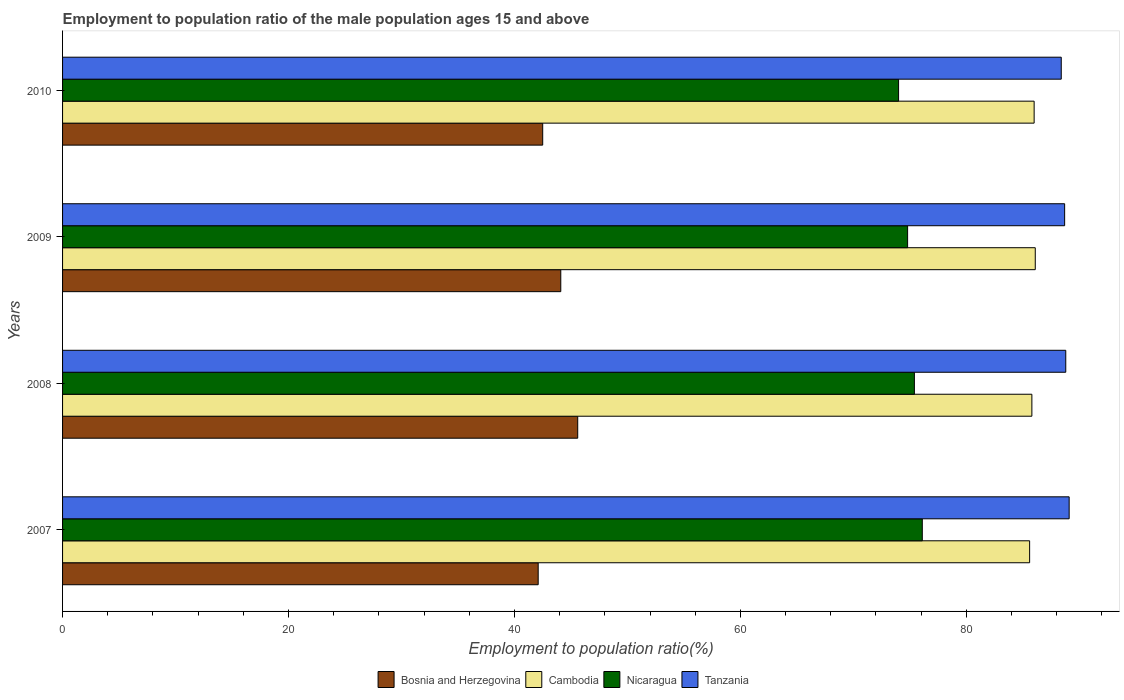How many different coloured bars are there?
Keep it short and to the point. 4. How many groups of bars are there?
Keep it short and to the point. 4. How many bars are there on the 4th tick from the top?
Provide a succinct answer. 4. What is the label of the 4th group of bars from the top?
Offer a terse response. 2007. In how many cases, is the number of bars for a given year not equal to the number of legend labels?
Keep it short and to the point. 0. What is the employment to population ratio in Nicaragua in 2008?
Your response must be concise. 75.4. Across all years, what is the maximum employment to population ratio in Nicaragua?
Your response must be concise. 76.1. Across all years, what is the minimum employment to population ratio in Bosnia and Herzegovina?
Your response must be concise. 42.1. In which year was the employment to population ratio in Nicaragua maximum?
Offer a very short reply. 2007. In which year was the employment to population ratio in Cambodia minimum?
Your answer should be compact. 2007. What is the total employment to population ratio in Nicaragua in the graph?
Your answer should be compact. 300.3. What is the difference between the employment to population ratio in Tanzania in 2009 and that in 2010?
Provide a short and direct response. 0.3. What is the difference between the employment to population ratio in Tanzania in 2010 and the employment to population ratio in Nicaragua in 2009?
Your answer should be very brief. 13.6. What is the average employment to population ratio in Cambodia per year?
Keep it short and to the point. 85.87. In the year 2007, what is the difference between the employment to population ratio in Cambodia and employment to population ratio in Nicaragua?
Your answer should be compact. 9.5. What is the ratio of the employment to population ratio in Nicaragua in 2007 to that in 2009?
Your response must be concise. 1.02. What is the difference between the highest and the second highest employment to population ratio in Cambodia?
Your answer should be compact. 0.1. What is the difference between the highest and the lowest employment to population ratio in Tanzania?
Make the answer very short. 0.7. Is the sum of the employment to population ratio in Cambodia in 2007 and 2009 greater than the maximum employment to population ratio in Bosnia and Herzegovina across all years?
Provide a succinct answer. Yes. What does the 3rd bar from the top in 2008 represents?
Provide a succinct answer. Cambodia. What does the 2nd bar from the bottom in 2010 represents?
Provide a short and direct response. Cambodia. Is it the case that in every year, the sum of the employment to population ratio in Cambodia and employment to population ratio in Tanzania is greater than the employment to population ratio in Nicaragua?
Your answer should be very brief. Yes. How many bars are there?
Provide a succinct answer. 16. Are all the bars in the graph horizontal?
Offer a very short reply. Yes. How many years are there in the graph?
Keep it short and to the point. 4. Are the values on the major ticks of X-axis written in scientific E-notation?
Provide a short and direct response. No. What is the title of the graph?
Your answer should be compact. Employment to population ratio of the male population ages 15 and above. What is the Employment to population ratio(%) of Bosnia and Herzegovina in 2007?
Your response must be concise. 42.1. What is the Employment to population ratio(%) in Cambodia in 2007?
Ensure brevity in your answer.  85.6. What is the Employment to population ratio(%) of Nicaragua in 2007?
Make the answer very short. 76.1. What is the Employment to population ratio(%) of Tanzania in 2007?
Keep it short and to the point. 89.1. What is the Employment to population ratio(%) in Bosnia and Herzegovina in 2008?
Offer a terse response. 45.6. What is the Employment to population ratio(%) of Cambodia in 2008?
Make the answer very short. 85.8. What is the Employment to population ratio(%) of Nicaragua in 2008?
Keep it short and to the point. 75.4. What is the Employment to population ratio(%) in Tanzania in 2008?
Make the answer very short. 88.8. What is the Employment to population ratio(%) in Bosnia and Herzegovina in 2009?
Your answer should be compact. 44.1. What is the Employment to population ratio(%) of Cambodia in 2009?
Give a very brief answer. 86.1. What is the Employment to population ratio(%) in Nicaragua in 2009?
Offer a very short reply. 74.8. What is the Employment to population ratio(%) in Tanzania in 2009?
Your answer should be very brief. 88.7. What is the Employment to population ratio(%) in Bosnia and Herzegovina in 2010?
Your response must be concise. 42.5. What is the Employment to population ratio(%) of Cambodia in 2010?
Ensure brevity in your answer.  86. What is the Employment to population ratio(%) in Tanzania in 2010?
Your answer should be compact. 88.4. Across all years, what is the maximum Employment to population ratio(%) of Bosnia and Herzegovina?
Give a very brief answer. 45.6. Across all years, what is the maximum Employment to population ratio(%) of Cambodia?
Make the answer very short. 86.1. Across all years, what is the maximum Employment to population ratio(%) in Nicaragua?
Keep it short and to the point. 76.1. Across all years, what is the maximum Employment to population ratio(%) of Tanzania?
Ensure brevity in your answer.  89.1. Across all years, what is the minimum Employment to population ratio(%) of Bosnia and Herzegovina?
Keep it short and to the point. 42.1. Across all years, what is the minimum Employment to population ratio(%) of Cambodia?
Give a very brief answer. 85.6. Across all years, what is the minimum Employment to population ratio(%) of Nicaragua?
Provide a short and direct response. 74. Across all years, what is the minimum Employment to population ratio(%) in Tanzania?
Give a very brief answer. 88.4. What is the total Employment to population ratio(%) of Bosnia and Herzegovina in the graph?
Provide a short and direct response. 174.3. What is the total Employment to population ratio(%) in Cambodia in the graph?
Your answer should be compact. 343.5. What is the total Employment to population ratio(%) in Nicaragua in the graph?
Your response must be concise. 300.3. What is the total Employment to population ratio(%) of Tanzania in the graph?
Offer a terse response. 355. What is the difference between the Employment to population ratio(%) in Bosnia and Herzegovina in 2007 and that in 2008?
Provide a succinct answer. -3.5. What is the difference between the Employment to population ratio(%) in Cambodia in 2007 and that in 2008?
Ensure brevity in your answer.  -0.2. What is the difference between the Employment to population ratio(%) of Bosnia and Herzegovina in 2007 and that in 2009?
Your answer should be compact. -2. What is the difference between the Employment to population ratio(%) of Nicaragua in 2007 and that in 2009?
Your response must be concise. 1.3. What is the difference between the Employment to population ratio(%) of Tanzania in 2007 and that in 2009?
Give a very brief answer. 0.4. What is the difference between the Employment to population ratio(%) in Cambodia in 2007 and that in 2010?
Your response must be concise. -0.4. What is the difference between the Employment to population ratio(%) of Tanzania in 2007 and that in 2010?
Give a very brief answer. 0.7. What is the difference between the Employment to population ratio(%) of Bosnia and Herzegovina in 2008 and that in 2009?
Your response must be concise. 1.5. What is the difference between the Employment to population ratio(%) of Nicaragua in 2008 and that in 2009?
Ensure brevity in your answer.  0.6. What is the difference between the Employment to population ratio(%) in Bosnia and Herzegovina in 2008 and that in 2010?
Make the answer very short. 3.1. What is the difference between the Employment to population ratio(%) of Tanzania in 2008 and that in 2010?
Provide a succinct answer. 0.4. What is the difference between the Employment to population ratio(%) in Cambodia in 2009 and that in 2010?
Make the answer very short. 0.1. What is the difference between the Employment to population ratio(%) in Bosnia and Herzegovina in 2007 and the Employment to population ratio(%) in Cambodia in 2008?
Your answer should be very brief. -43.7. What is the difference between the Employment to population ratio(%) in Bosnia and Herzegovina in 2007 and the Employment to population ratio(%) in Nicaragua in 2008?
Offer a very short reply. -33.3. What is the difference between the Employment to population ratio(%) of Bosnia and Herzegovina in 2007 and the Employment to population ratio(%) of Tanzania in 2008?
Ensure brevity in your answer.  -46.7. What is the difference between the Employment to population ratio(%) of Nicaragua in 2007 and the Employment to population ratio(%) of Tanzania in 2008?
Make the answer very short. -12.7. What is the difference between the Employment to population ratio(%) of Bosnia and Herzegovina in 2007 and the Employment to population ratio(%) of Cambodia in 2009?
Provide a short and direct response. -44. What is the difference between the Employment to population ratio(%) in Bosnia and Herzegovina in 2007 and the Employment to population ratio(%) in Nicaragua in 2009?
Keep it short and to the point. -32.7. What is the difference between the Employment to population ratio(%) in Bosnia and Herzegovina in 2007 and the Employment to population ratio(%) in Tanzania in 2009?
Your answer should be very brief. -46.6. What is the difference between the Employment to population ratio(%) in Cambodia in 2007 and the Employment to population ratio(%) in Tanzania in 2009?
Keep it short and to the point. -3.1. What is the difference between the Employment to population ratio(%) in Bosnia and Herzegovina in 2007 and the Employment to population ratio(%) in Cambodia in 2010?
Your answer should be very brief. -43.9. What is the difference between the Employment to population ratio(%) of Bosnia and Herzegovina in 2007 and the Employment to population ratio(%) of Nicaragua in 2010?
Offer a very short reply. -31.9. What is the difference between the Employment to population ratio(%) in Bosnia and Herzegovina in 2007 and the Employment to population ratio(%) in Tanzania in 2010?
Offer a very short reply. -46.3. What is the difference between the Employment to population ratio(%) in Nicaragua in 2007 and the Employment to population ratio(%) in Tanzania in 2010?
Your answer should be very brief. -12.3. What is the difference between the Employment to population ratio(%) of Bosnia and Herzegovina in 2008 and the Employment to population ratio(%) of Cambodia in 2009?
Provide a succinct answer. -40.5. What is the difference between the Employment to population ratio(%) in Bosnia and Herzegovina in 2008 and the Employment to population ratio(%) in Nicaragua in 2009?
Provide a succinct answer. -29.2. What is the difference between the Employment to population ratio(%) in Bosnia and Herzegovina in 2008 and the Employment to population ratio(%) in Tanzania in 2009?
Ensure brevity in your answer.  -43.1. What is the difference between the Employment to population ratio(%) of Cambodia in 2008 and the Employment to population ratio(%) of Tanzania in 2009?
Your answer should be compact. -2.9. What is the difference between the Employment to population ratio(%) of Bosnia and Herzegovina in 2008 and the Employment to population ratio(%) of Cambodia in 2010?
Ensure brevity in your answer.  -40.4. What is the difference between the Employment to population ratio(%) of Bosnia and Herzegovina in 2008 and the Employment to population ratio(%) of Nicaragua in 2010?
Offer a very short reply. -28.4. What is the difference between the Employment to population ratio(%) of Bosnia and Herzegovina in 2008 and the Employment to population ratio(%) of Tanzania in 2010?
Give a very brief answer. -42.8. What is the difference between the Employment to population ratio(%) in Cambodia in 2008 and the Employment to population ratio(%) in Nicaragua in 2010?
Ensure brevity in your answer.  11.8. What is the difference between the Employment to population ratio(%) of Nicaragua in 2008 and the Employment to population ratio(%) of Tanzania in 2010?
Offer a terse response. -13. What is the difference between the Employment to population ratio(%) in Bosnia and Herzegovina in 2009 and the Employment to population ratio(%) in Cambodia in 2010?
Your response must be concise. -41.9. What is the difference between the Employment to population ratio(%) of Bosnia and Herzegovina in 2009 and the Employment to population ratio(%) of Nicaragua in 2010?
Make the answer very short. -29.9. What is the difference between the Employment to population ratio(%) of Bosnia and Herzegovina in 2009 and the Employment to population ratio(%) of Tanzania in 2010?
Your response must be concise. -44.3. What is the difference between the Employment to population ratio(%) in Cambodia in 2009 and the Employment to population ratio(%) in Nicaragua in 2010?
Your answer should be compact. 12.1. What is the difference between the Employment to population ratio(%) in Cambodia in 2009 and the Employment to population ratio(%) in Tanzania in 2010?
Ensure brevity in your answer.  -2.3. What is the difference between the Employment to population ratio(%) in Nicaragua in 2009 and the Employment to population ratio(%) in Tanzania in 2010?
Provide a short and direct response. -13.6. What is the average Employment to population ratio(%) in Bosnia and Herzegovina per year?
Your answer should be compact. 43.58. What is the average Employment to population ratio(%) of Cambodia per year?
Provide a short and direct response. 85.88. What is the average Employment to population ratio(%) of Nicaragua per year?
Keep it short and to the point. 75.08. What is the average Employment to population ratio(%) in Tanzania per year?
Your answer should be very brief. 88.75. In the year 2007, what is the difference between the Employment to population ratio(%) in Bosnia and Herzegovina and Employment to population ratio(%) in Cambodia?
Offer a terse response. -43.5. In the year 2007, what is the difference between the Employment to population ratio(%) of Bosnia and Herzegovina and Employment to population ratio(%) of Nicaragua?
Make the answer very short. -34. In the year 2007, what is the difference between the Employment to population ratio(%) in Bosnia and Herzegovina and Employment to population ratio(%) in Tanzania?
Ensure brevity in your answer.  -47. In the year 2008, what is the difference between the Employment to population ratio(%) in Bosnia and Herzegovina and Employment to population ratio(%) in Cambodia?
Your answer should be compact. -40.2. In the year 2008, what is the difference between the Employment to population ratio(%) of Bosnia and Herzegovina and Employment to population ratio(%) of Nicaragua?
Give a very brief answer. -29.8. In the year 2008, what is the difference between the Employment to population ratio(%) of Bosnia and Herzegovina and Employment to population ratio(%) of Tanzania?
Offer a very short reply. -43.2. In the year 2008, what is the difference between the Employment to population ratio(%) in Cambodia and Employment to population ratio(%) in Nicaragua?
Your answer should be very brief. 10.4. In the year 2008, what is the difference between the Employment to population ratio(%) in Nicaragua and Employment to population ratio(%) in Tanzania?
Your answer should be very brief. -13.4. In the year 2009, what is the difference between the Employment to population ratio(%) of Bosnia and Herzegovina and Employment to population ratio(%) of Cambodia?
Your answer should be very brief. -42. In the year 2009, what is the difference between the Employment to population ratio(%) in Bosnia and Herzegovina and Employment to population ratio(%) in Nicaragua?
Make the answer very short. -30.7. In the year 2009, what is the difference between the Employment to population ratio(%) in Bosnia and Herzegovina and Employment to population ratio(%) in Tanzania?
Offer a terse response. -44.6. In the year 2009, what is the difference between the Employment to population ratio(%) of Cambodia and Employment to population ratio(%) of Nicaragua?
Ensure brevity in your answer.  11.3. In the year 2009, what is the difference between the Employment to population ratio(%) of Nicaragua and Employment to population ratio(%) of Tanzania?
Offer a terse response. -13.9. In the year 2010, what is the difference between the Employment to population ratio(%) in Bosnia and Herzegovina and Employment to population ratio(%) in Cambodia?
Offer a terse response. -43.5. In the year 2010, what is the difference between the Employment to population ratio(%) of Bosnia and Herzegovina and Employment to population ratio(%) of Nicaragua?
Your answer should be compact. -31.5. In the year 2010, what is the difference between the Employment to population ratio(%) in Bosnia and Herzegovina and Employment to population ratio(%) in Tanzania?
Your answer should be very brief. -45.9. In the year 2010, what is the difference between the Employment to population ratio(%) of Cambodia and Employment to population ratio(%) of Nicaragua?
Make the answer very short. 12. In the year 2010, what is the difference between the Employment to population ratio(%) in Cambodia and Employment to population ratio(%) in Tanzania?
Offer a terse response. -2.4. In the year 2010, what is the difference between the Employment to population ratio(%) of Nicaragua and Employment to population ratio(%) of Tanzania?
Give a very brief answer. -14.4. What is the ratio of the Employment to population ratio(%) of Bosnia and Herzegovina in 2007 to that in 2008?
Provide a succinct answer. 0.92. What is the ratio of the Employment to population ratio(%) in Nicaragua in 2007 to that in 2008?
Provide a succinct answer. 1.01. What is the ratio of the Employment to population ratio(%) in Tanzania in 2007 to that in 2008?
Provide a succinct answer. 1. What is the ratio of the Employment to population ratio(%) in Bosnia and Herzegovina in 2007 to that in 2009?
Give a very brief answer. 0.95. What is the ratio of the Employment to population ratio(%) of Nicaragua in 2007 to that in 2009?
Offer a terse response. 1.02. What is the ratio of the Employment to population ratio(%) in Tanzania in 2007 to that in 2009?
Provide a short and direct response. 1. What is the ratio of the Employment to population ratio(%) of Bosnia and Herzegovina in 2007 to that in 2010?
Provide a succinct answer. 0.99. What is the ratio of the Employment to population ratio(%) in Nicaragua in 2007 to that in 2010?
Your answer should be very brief. 1.03. What is the ratio of the Employment to population ratio(%) of Tanzania in 2007 to that in 2010?
Provide a succinct answer. 1.01. What is the ratio of the Employment to population ratio(%) in Bosnia and Herzegovina in 2008 to that in 2009?
Your answer should be compact. 1.03. What is the ratio of the Employment to population ratio(%) of Nicaragua in 2008 to that in 2009?
Provide a succinct answer. 1.01. What is the ratio of the Employment to population ratio(%) in Tanzania in 2008 to that in 2009?
Offer a terse response. 1. What is the ratio of the Employment to population ratio(%) in Bosnia and Herzegovina in 2008 to that in 2010?
Your response must be concise. 1.07. What is the ratio of the Employment to population ratio(%) of Cambodia in 2008 to that in 2010?
Give a very brief answer. 1. What is the ratio of the Employment to population ratio(%) of Nicaragua in 2008 to that in 2010?
Your answer should be very brief. 1.02. What is the ratio of the Employment to population ratio(%) of Bosnia and Herzegovina in 2009 to that in 2010?
Your answer should be compact. 1.04. What is the ratio of the Employment to population ratio(%) in Nicaragua in 2009 to that in 2010?
Your answer should be very brief. 1.01. What is the ratio of the Employment to population ratio(%) of Tanzania in 2009 to that in 2010?
Your response must be concise. 1. What is the difference between the highest and the second highest Employment to population ratio(%) of Cambodia?
Offer a terse response. 0.1. What is the difference between the highest and the second highest Employment to population ratio(%) in Nicaragua?
Your answer should be very brief. 0.7. 